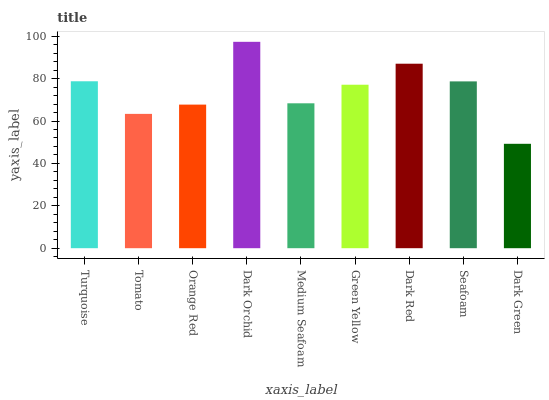Is Tomato the minimum?
Answer yes or no. No. Is Tomato the maximum?
Answer yes or no. No. Is Turquoise greater than Tomato?
Answer yes or no. Yes. Is Tomato less than Turquoise?
Answer yes or no. Yes. Is Tomato greater than Turquoise?
Answer yes or no. No. Is Turquoise less than Tomato?
Answer yes or no. No. Is Green Yellow the high median?
Answer yes or no. Yes. Is Green Yellow the low median?
Answer yes or no. Yes. Is Orange Red the high median?
Answer yes or no. No. Is Medium Seafoam the low median?
Answer yes or no. No. 